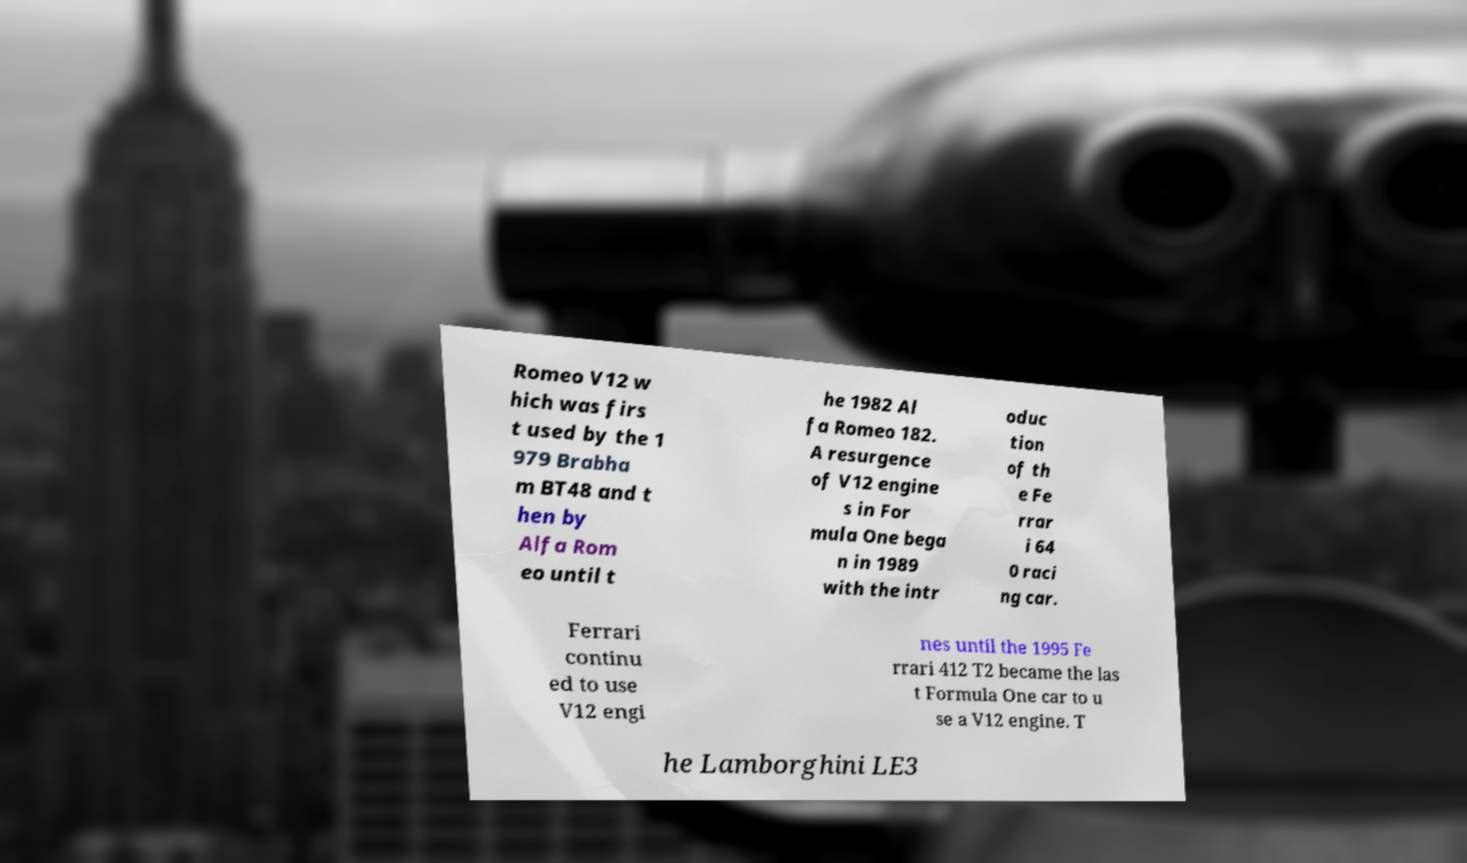Can you accurately transcribe the text from the provided image for me? Romeo V12 w hich was firs t used by the 1 979 Brabha m BT48 and t hen by Alfa Rom eo until t he 1982 Al fa Romeo 182. A resurgence of V12 engine s in For mula One bega n in 1989 with the intr oduc tion of th e Fe rrar i 64 0 raci ng car. Ferrari continu ed to use V12 engi nes until the 1995 Fe rrari 412 T2 became the las t Formula One car to u se a V12 engine. T he Lamborghini LE3 